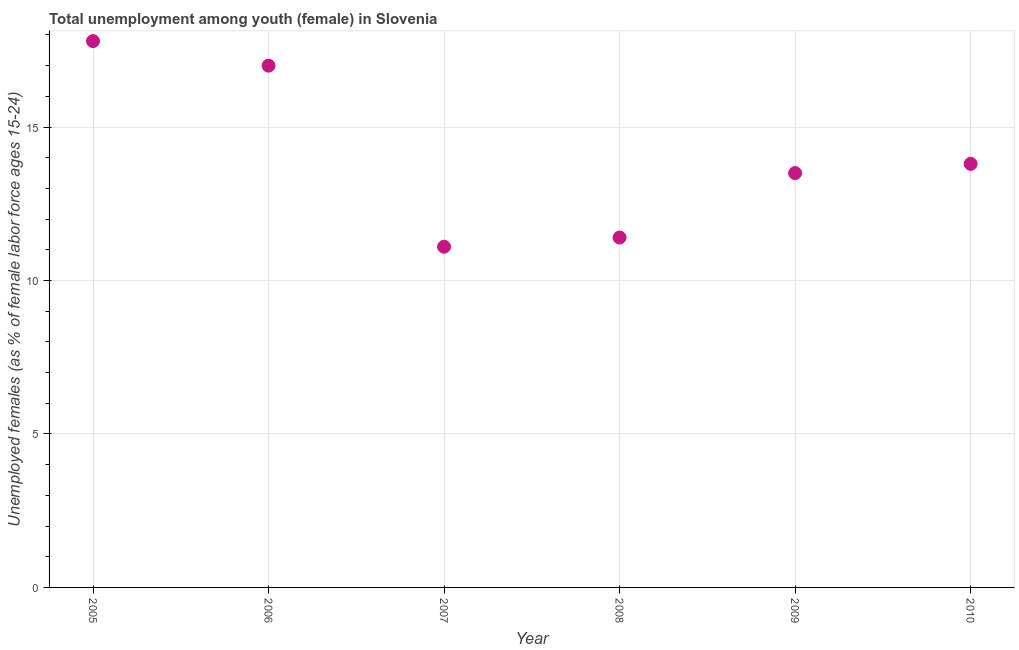What is the unemployed female youth population in 2010?
Your answer should be very brief. 13.8. Across all years, what is the maximum unemployed female youth population?
Offer a very short reply. 17.8. Across all years, what is the minimum unemployed female youth population?
Your response must be concise. 11.1. In which year was the unemployed female youth population maximum?
Give a very brief answer. 2005. In which year was the unemployed female youth population minimum?
Provide a short and direct response. 2007. What is the sum of the unemployed female youth population?
Provide a short and direct response. 84.6. What is the difference between the unemployed female youth population in 2008 and 2009?
Make the answer very short. -2.1. What is the average unemployed female youth population per year?
Keep it short and to the point. 14.1. What is the median unemployed female youth population?
Provide a short and direct response. 13.65. What is the ratio of the unemployed female youth population in 2005 to that in 2009?
Your answer should be very brief. 1.32. Is the difference between the unemployed female youth population in 2008 and 2009 greater than the difference between any two years?
Give a very brief answer. No. What is the difference between the highest and the second highest unemployed female youth population?
Provide a short and direct response. 0.8. What is the difference between the highest and the lowest unemployed female youth population?
Provide a succinct answer. 6.7. In how many years, is the unemployed female youth population greater than the average unemployed female youth population taken over all years?
Your response must be concise. 2. Are the values on the major ticks of Y-axis written in scientific E-notation?
Your answer should be very brief. No. What is the title of the graph?
Your answer should be very brief. Total unemployment among youth (female) in Slovenia. What is the label or title of the Y-axis?
Your answer should be very brief. Unemployed females (as % of female labor force ages 15-24). What is the Unemployed females (as % of female labor force ages 15-24) in 2005?
Give a very brief answer. 17.8. What is the Unemployed females (as % of female labor force ages 15-24) in 2007?
Keep it short and to the point. 11.1. What is the Unemployed females (as % of female labor force ages 15-24) in 2008?
Your response must be concise. 11.4. What is the Unemployed females (as % of female labor force ages 15-24) in 2010?
Offer a terse response. 13.8. What is the difference between the Unemployed females (as % of female labor force ages 15-24) in 2005 and 2006?
Ensure brevity in your answer.  0.8. What is the difference between the Unemployed females (as % of female labor force ages 15-24) in 2005 and 2009?
Ensure brevity in your answer.  4.3. What is the difference between the Unemployed females (as % of female labor force ages 15-24) in 2006 and 2007?
Offer a terse response. 5.9. What is the difference between the Unemployed females (as % of female labor force ages 15-24) in 2006 and 2008?
Offer a terse response. 5.6. What is the difference between the Unemployed females (as % of female labor force ages 15-24) in 2007 and 2010?
Give a very brief answer. -2.7. What is the difference between the Unemployed females (as % of female labor force ages 15-24) in 2008 and 2010?
Your answer should be compact. -2.4. What is the difference between the Unemployed females (as % of female labor force ages 15-24) in 2009 and 2010?
Provide a succinct answer. -0.3. What is the ratio of the Unemployed females (as % of female labor force ages 15-24) in 2005 to that in 2006?
Your answer should be very brief. 1.05. What is the ratio of the Unemployed females (as % of female labor force ages 15-24) in 2005 to that in 2007?
Your response must be concise. 1.6. What is the ratio of the Unemployed females (as % of female labor force ages 15-24) in 2005 to that in 2008?
Keep it short and to the point. 1.56. What is the ratio of the Unemployed females (as % of female labor force ages 15-24) in 2005 to that in 2009?
Give a very brief answer. 1.32. What is the ratio of the Unemployed females (as % of female labor force ages 15-24) in 2005 to that in 2010?
Offer a terse response. 1.29. What is the ratio of the Unemployed females (as % of female labor force ages 15-24) in 2006 to that in 2007?
Provide a succinct answer. 1.53. What is the ratio of the Unemployed females (as % of female labor force ages 15-24) in 2006 to that in 2008?
Keep it short and to the point. 1.49. What is the ratio of the Unemployed females (as % of female labor force ages 15-24) in 2006 to that in 2009?
Your response must be concise. 1.26. What is the ratio of the Unemployed females (as % of female labor force ages 15-24) in 2006 to that in 2010?
Give a very brief answer. 1.23. What is the ratio of the Unemployed females (as % of female labor force ages 15-24) in 2007 to that in 2008?
Provide a short and direct response. 0.97. What is the ratio of the Unemployed females (as % of female labor force ages 15-24) in 2007 to that in 2009?
Offer a terse response. 0.82. What is the ratio of the Unemployed females (as % of female labor force ages 15-24) in 2007 to that in 2010?
Give a very brief answer. 0.8. What is the ratio of the Unemployed females (as % of female labor force ages 15-24) in 2008 to that in 2009?
Your response must be concise. 0.84. What is the ratio of the Unemployed females (as % of female labor force ages 15-24) in 2008 to that in 2010?
Your answer should be compact. 0.83. 